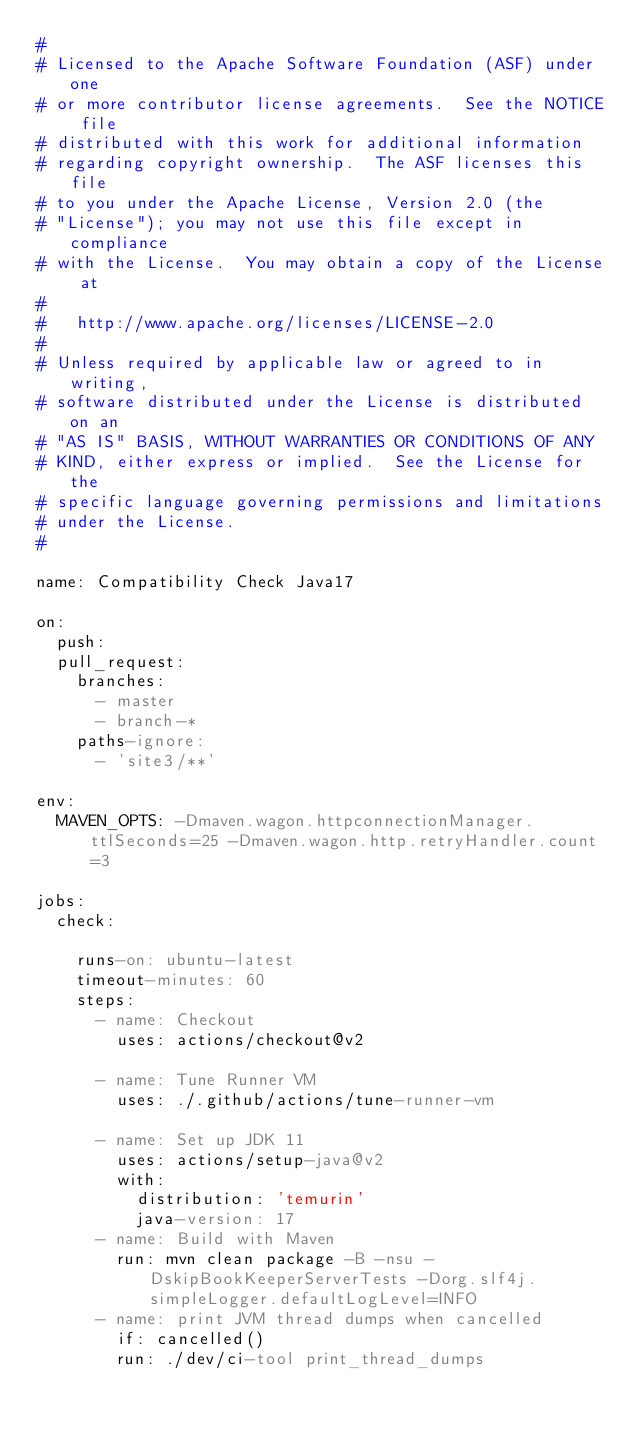<code> <loc_0><loc_0><loc_500><loc_500><_YAML_>#
# Licensed to the Apache Software Foundation (ASF) under one
# or more contributor license agreements.  See the NOTICE file
# distributed with this work for additional information
# regarding copyright ownership.  The ASF licenses this file
# to you under the Apache License, Version 2.0 (the
# "License"); you may not use this file except in compliance
# with the License.  You may obtain a copy of the License at
#
#   http://www.apache.org/licenses/LICENSE-2.0
#
# Unless required by applicable law or agreed to in writing,
# software distributed under the License is distributed on an
# "AS IS" BASIS, WITHOUT WARRANTIES OR CONDITIONS OF ANY
# KIND, either express or implied.  See the License for the
# specific language governing permissions and limitations
# under the License.
#

name: Compatibility Check Java17

on:
  push:
  pull_request:
    branches:
      - master
      - branch-*
    paths-ignore:
      - 'site3/**'

env:
  MAVEN_OPTS: -Dmaven.wagon.httpconnectionManager.ttlSeconds=25 -Dmaven.wagon.http.retryHandler.count=3

jobs:
  check:

    runs-on: ubuntu-latest
    timeout-minutes: 60
    steps:
      - name: Checkout
        uses: actions/checkout@v2

      - name: Tune Runner VM
        uses: ./.github/actions/tune-runner-vm

      - name: Set up JDK 11
        uses: actions/setup-java@v2
        with:
          distribution: 'temurin'
          java-version: 17
      - name: Build with Maven
        run: mvn clean package -B -nsu -DskipBookKeeperServerTests -Dorg.slf4j.simpleLogger.defaultLogLevel=INFO
      - name: print JVM thread dumps when cancelled
        if: cancelled()
        run: ./dev/ci-tool print_thread_dumps
</code> 